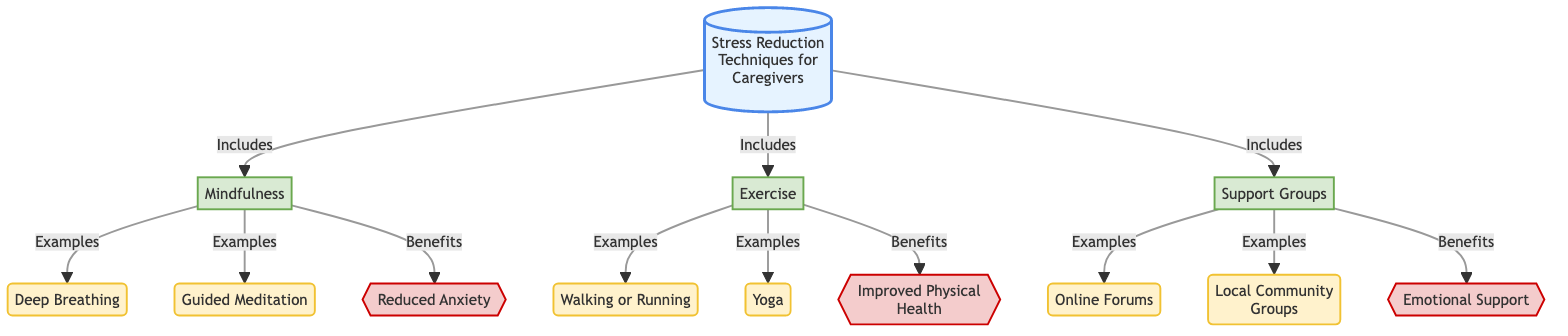What are the three main stress reduction techniques listed in the diagram? The diagram identifies three main techniques: Mindfulness, Exercise, and Support Groups. This is directly observed from the connecting lines pointing to these three techniques from the main title.
Answer: Mindfulness, Exercise, Support Groups How many examples are listed under mindfulness? The diagram provides two examples under the mindfulness technique: Deep Breathing and Guided Meditation. Counting these examples in the flowchart reveals a total of two.
Answer: 2 Which technique is linked to improved physical health? Exercise is the technique linked to the benefit of Improved Physical Health, as indicated by the line drawn from Exercise to this specific benefit in the flowchart.
Answer: Exercise What is one of the benefits of support groups? Emotional Support is one of the benefits linked to Support Groups, as shown by the line that connects these two nodes in the diagram.
Answer: Emotional Support How many total benefits are outlined in the diagram? The diagram outlines three benefits: Reduced Anxiety, Improved Physical Health, and Emotional Support. This can be verified by counting the connections leading to the benefits section.
Answer: 3 Which technique has examples of online forums? The Support Groups technique has an example linked to Online Forums, indicating that this falls under support group strategies as highlighted in the flowchart.
Answer: Support Groups What is the first example listed under exercise? The first example listed under exercise in the diagram is Walking or Running, as directly interpreted from the flowchart structure.
Answer: Walking or Running 